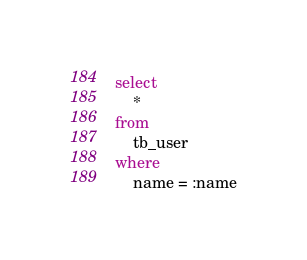Convert code to text. <code><loc_0><loc_0><loc_500><loc_500><_SQL_>select
	*
from
	tb_user
where
	name = :name</code> 